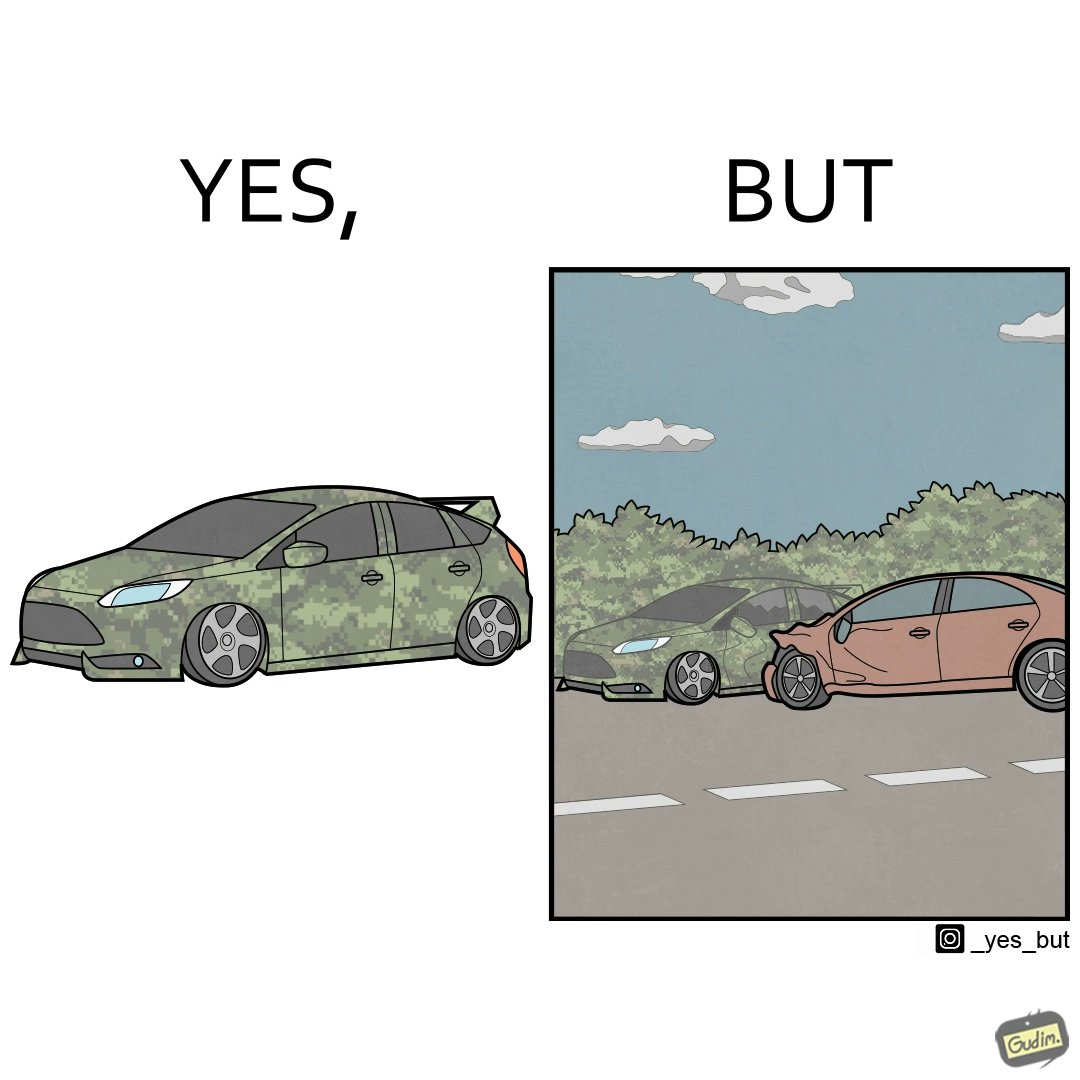What does this image depict? The image is ironic, because in the left image a car is painted in camouflage color but in the right image the same car is getting involved in accident to due to its color as other drivers face difficulty in recognizing the colors 